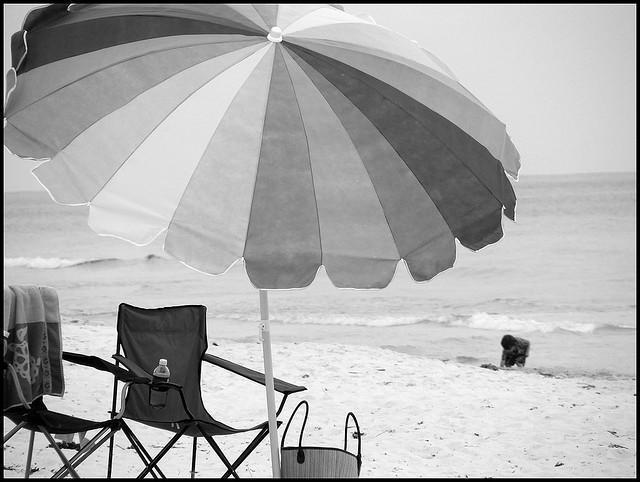How many chairs are in the picture?
Give a very brief answer. 2. 